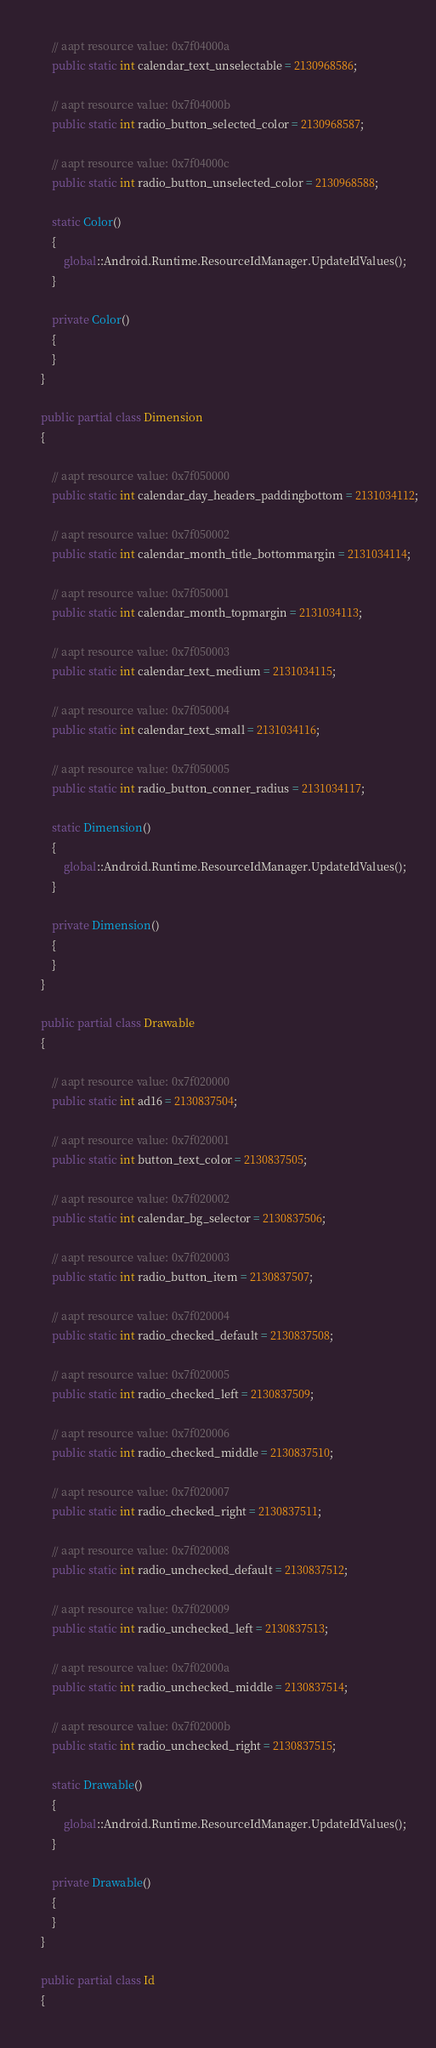Convert code to text. <code><loc_0><loc_0><loc_500><loc_500><_C#_>			
			// aapt resource value: 0x7f04000a
			public static int calendar_text_unselectable = 2130968586;
			
			// aapt resource value: 0x7f04000b
			public static int radio_button_selected_color = 2130968587;
			
			// aapt resource value: 0x7f04000c
			public static int radio_button_unselected_color = 2130968588;
			
			static Color()
			{
				global::Android.Runtime.ResourceIdManager.UpdateIdValues();
			}
			
			private Color()
			{
			}
		}
		
		public partial class Dimension
		{
			
			// aapt resource value: 0x7f050000
			public static int calendar_day_headers_paddingbottom = 2131034112;
			
			// aapt resource value: 0x7f050002
			public static int calendar_month_title_bottommargin = 2131034114;
			
			// aapt resource value: 0x7f050001
			public static int calendar_month_topmargin = 2131034113;
			
			// aapt resource value: 0x7f050003
			public static int calendar_text_medium = 2131034115;
			
			// aapt resource value: 0x7f050004
			public static int calendar_text_small = 2131034116;
			
			// aapt resource value: 0x7f050005
			public static int radio_button_conner_radius = 2131034117;
			
			static Dimension()
			{
				global::Android.Runtime.ResourceIdManager.UpdateIdValues();
			}
			
			private Dimension()
			{
			}
		}
		
		public partial class Drawable
		{
			
			// aapt resource value: 0x7f020000
			public static int ad16 = 2130837504;
			
			// aapt resource value: 0x7f020001
			public static int button_text_color = 2130837505;
			
			// aapt resource value: 0x7f020002
			public static int calendar_bg_selector = 2130837506;
			
			// aapt resource value: 0x7f020003
			public static int radio_button_item = 2130837507;
			
			// aapt resource value: 0x7f020004
			public static int radio_checked_default = 2130837508;
			
			// aapt resource value: 0x7f020005
			public static int radio_checked_left = 2130837509;
			
			// aapt resource value: 0x7f020006
			public static int radio_checked_middle = 2130837510;
			
			// aapt resource value: 0x7f020007
			public static int radio_checked_right = 2130837511;
			
			// aapt resource value: 0x7f020008
			public static int radio_unchecked_default = 2130837512;
			
			// aapt resource value: 0x7f020009
			public static int radio_unchecked_left = 2130837513;
			
			// aapt resource value: 0x7f02000a
			public static int radio_unchecked_middle = 2130837514;
			
			// aapt resource value: 0x7f02000b
			public static int radio_unchecked_right = 2130837515;
			
			static Drawable()
			{
				global::Android.Runtime.ResourceIdManager.UpdateIdValues();
			}
			
			private Drawable()
			{
			}
		}
		
		public partial class Id
		{
			</code> 